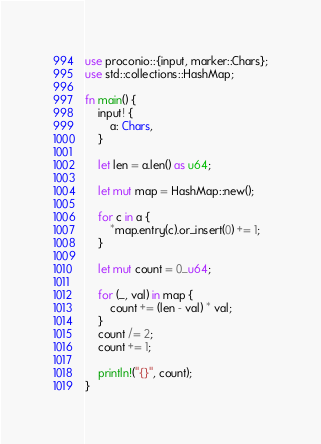<code> <loc_0><loc_0><loc_500><loc_500><_Rust_>use proconio::{input, marker::Chars};
use std::collections::HashMap;

fn main() {
    input! {
        a: Chars,
    }

    let len = a.len() as u64;

    let mut map = HashMap::new();

    for c in a {
        *map.entry(c).or_insert(0) += 1;
    }

    let mut count = 0_u64;

    for (_, val) in map {
        count += (len - val) * val;
    }
    count /= 2;
    count += 1;

    println!("{}", count);
}
</code> 